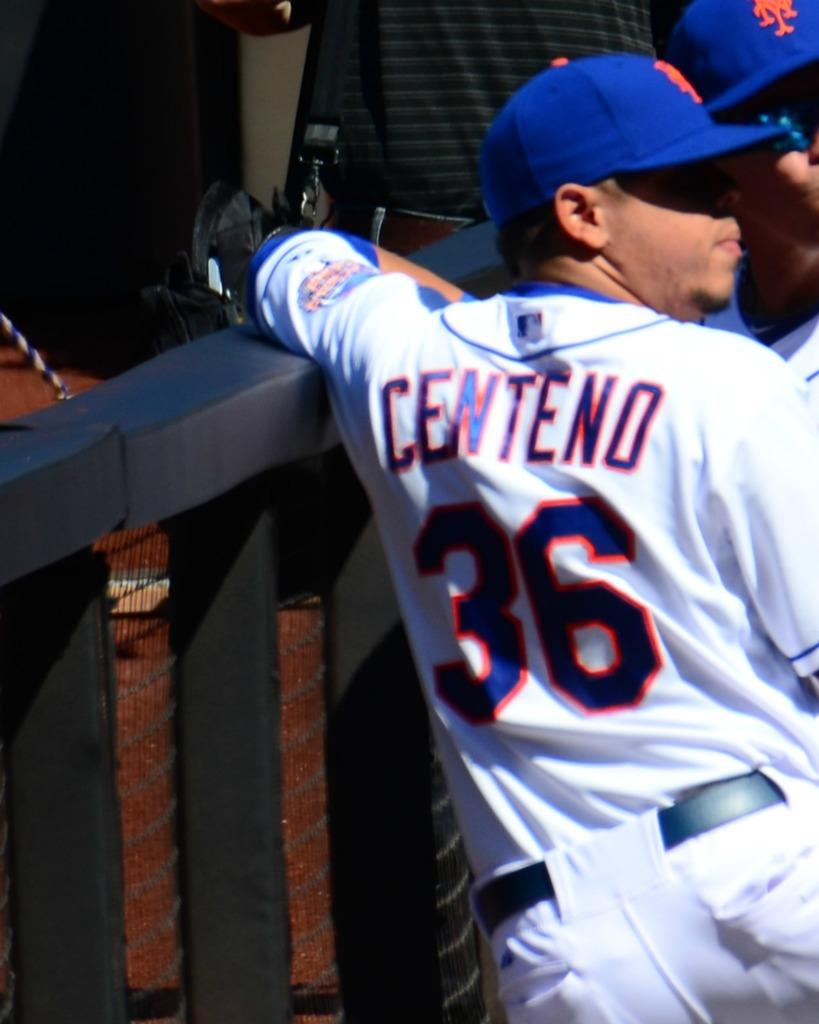Provide a one-sentence caption for the provided image. Baseball player Centeno wears jersey number 36 for the New York Mets. 